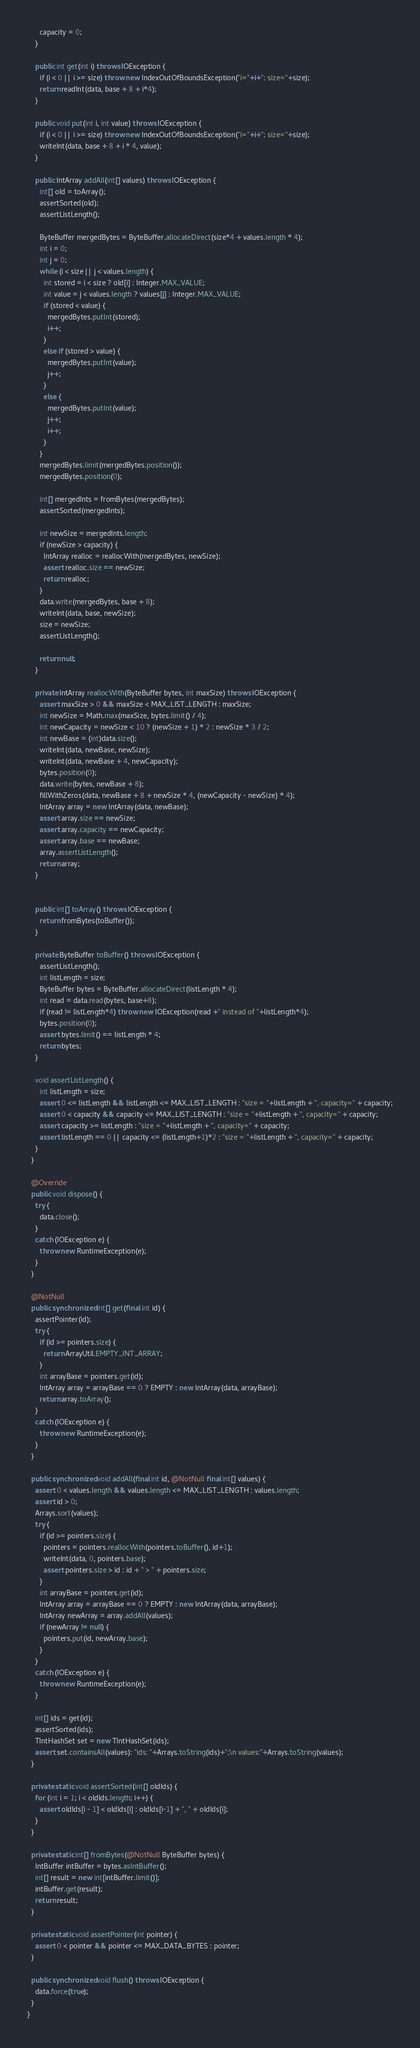<code> <loc_0><loc_0><loc_500><loc_500><_Java_>      capacity = 0;
    }

    public int get(int i) throws IOException {
      if (i < 0 || i >= size) throw new IndexOutOfBoundsException("i="+i+"; size="+size);
      return readInt(data, base + 8 + i*4);
    }

    public void put(int i, int value) throws IOException {
      if (i < 0 || i >= size) throw new IndexOutOfBoundsException("i="+i+"; size="+size);
      writeInt(data, base + 8 + i * 4, value);
    }

    public IntArray addAll(int[] values) throws IOException {
      int[] old = toArray();
      assertSorted(old);
      assertListLength();

      ByteBuffer mergedBytes = ByteBuffer.allocateDirect(size*4 + values.length * 4);
      int i = 0;
      int j = 0;
      while (i < size || j < values.length) {
        int stored = i < size ? old[i] : Integer.MAX_VALUE;
        int value = j < values.length ? values[j] : Integer.MAX_VALUE;
        if (stored < value) {
          mergedBytes.putInt(stored);
          i++;
        }
        else if (stored > value) {
          mergedBytes.putInt(value);
          j++;
        }
        else {
          mergedBytes.putInt(value);
          j++;
          i++;
        }
      }
      mergedBytes.limit(mergedBytes.position());
      mergedBytes.position(0);

      int[] mergedInts = fromBytes(mergedBytes);
      assertSorted(mergedInts);

      int newSize = mergedInts.length;
      if (newSize > capacity) {
        IntArray realloc = reallocWith(mergedBytes, newSize);
        assert realloc.size == newSize;
        return realloc;
      }
      data.write(mergedBytes, base + 8);
      writeInt(data, base, newSize);
      size = newSize;
      assertListLength();

      return null;
    }

    private IntArray reallocWith(ByteBuffer bytes, int maxSize) throws IOException {
      assert maxSize > 0 && maxSize < MAX_LIST_LENGTH : maxSize;
      int newSize = Math.max(maxSize, bytes.limit() / 4);
      int newCapacity = newSize < 10 ? (newSize + 1) * 2 : newSize * 3 / 2;
      int newBase = (int)data.size();
      writeInt(data, newBase, newSize);
      writeInt(data, newBase + 4, newCapacity);
      bytes.position(0);
      data.write(bytes, newBase + 8);
      fillWithZeros(data, newBase + 8 + newSize * 4, (newCapacity - newSize) * 4);
      IntArray array = new IntArray(data, newBase);
      assert array.size == newSize;
      assert array.capacity == newCapacity;
      assert array.base == newBase;
      array.assertListLength();
      return array;
    }


    public int[] toArray() throws IOException {
      return fromBytes(toBuffer());
    }

    private ByteBuffer toBuffer() throws IOException {
      assertListLength();
      int listLength = size;
      ByteBuffer bytes = ByteBuffer.allocateDirect(listLength * 4);
      int read = data.read(bytes, base+8);
      if (read != listLength*4) throw new IOException(read +" instead of "+listLength*4);
      bytes.position(0);
      assert bytes.limit() == listLength * 4;
      return bytes;
    }

    void assertListLength() {
      int listLength = size;
      assert 0 <= listLength && listLength <= MAX_LIST_LENGTH : "size = "+listLength + ", capacity=" + capacity;
      assert 0 < capacity && capacity <= MAX_LIST_LENGTH : "size = "+listLength + ", capacity=" + capacity;
      assert capacity >= listLength : "size = "+listLength + ", capacity=" + capacity;
      assert listLength == 0 || capacity <= (listLength+1)*2 : "size = "+listLength + ", capacity=" + capacity;
    }
  }

  @Override
  public void dispose() {
    try {
      data.close();
    }
    catch (IOException e) {
      throw new RuntimeException(e);
    }
  }

  @NotNull
  public synchronized int[] get(final int id) {
    assertPointer(id);
    try {
      if (id >= pointers.size) {
        return ArrayUtil.EMPTY_INT_ARRAY;
      }
      int arrayBase = pointers.get(id);
      IntArray array = arrayBase == 0 ? EMPTY : new IntArray(data, arrayBase);
      return array.toArray();
    }
    catch (IOException e) {
      throw new RuntimeException(e);
    }
  }

  public synchronized void addAll(final int id, @NotNull final int[] values) {
    assert 0 < values.length && values.length <= MAX_LIST_LENGTH : values.length;
    assert id > 0;
    Arrays.sort(values);
    try {
      if (id >= pointers.size) {
        pointers = pointers.reallocWith(pointers.toBuffer(), id+1);
        writeInt(data, 0, pointers.base);
        assert pointers.size > id : id + " > " + pointers.size;
      }
      int arrayBase = pointers.get(id);
      IntArray array = arrayBase == 0 ? EMPTY : new IntArray(data, arrayBase);
      IntArray newArray = array.addAll(values);
      if (newArray != null) {
        pointers.put(id, newArray.base);
      }
    }
    catch (IOException e) {
      throw new RuntimeException(e);
    }

    int[] ids = get(id);
    assertSorted(ids);
    TIntHashSet set = new TIntHashSet(ids);
    assert set.containsAll(values): "ids: "+Arrays.toString(ids)+";\n values:"+Arrays.toString(values);
  }

  private static void assertSorted(int[] oldIds) {
    for (int i = 1; i < oldIds.length; i++) {
      assert oldIds[i - 1] < oldIds[i] : oldIds[i-1] + ", " + oldIds[i];
    }
  }

  private static int[] fromBytes(@NotNull ByteBuffer bytes) {
    IntBuffer intBuffer = bytes.asIntBuffer();
    int[] result = new int[intBuffer.limit()];
    intBuffer.get(result);
    return result;
  }

  private static void assertPointer(int pointer) {
    assert 0 < pointer && pointer <= MAX_DATA_BYTES : pointer;
  }

  public synchronized void flush() throws IOException {
    data.force(true);
  }
}
</code> 